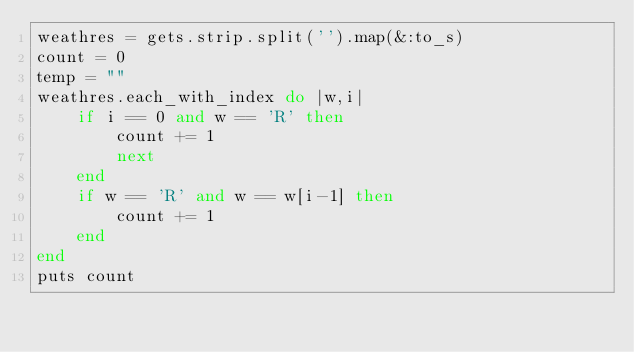<code> <loc_0><loc_0><loc_500><loc_500><_Ruby_>weathres = gets.strip.split('').map(&:to_s)
count = 0
temp = ""
weathres.each_with_index do |w,i|
    if i == 0 and w == 'R' then
        count += 1
        next
    end
    if w == 'R' and w == w[i-1] then
        count += 1
    end
end
puts count</code> 